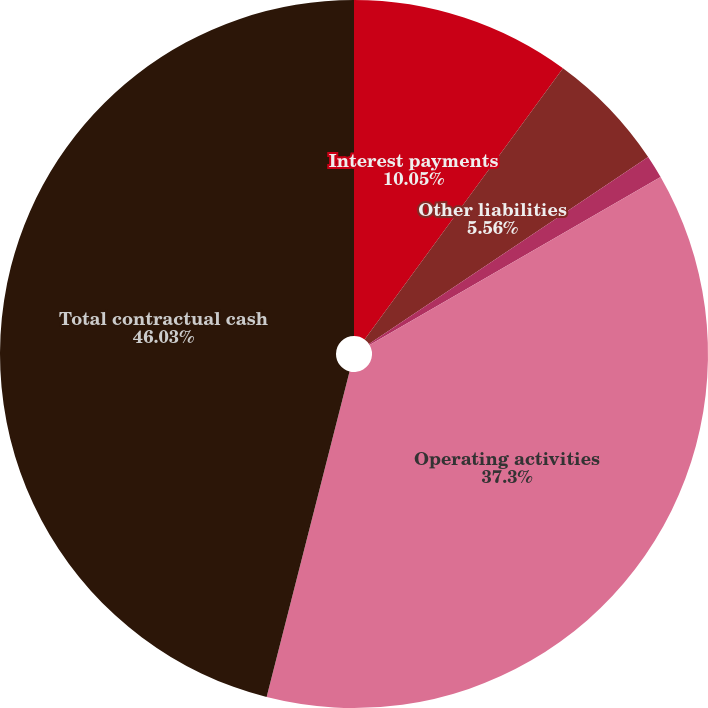Convert chart. <chart><loc_0><loc_0><loc_500><loc_500><pie_chart><fcel>Interest payments<fcel>Other liabilities<fcel>Operating lease obligations<fcel>Operating activities<fcel>Total contractual cash<nl><fcel>10.05%<fcel>5.56%<fcel>1.06%<fcel>37.3%<fcel>46.03%<nl></chart> 